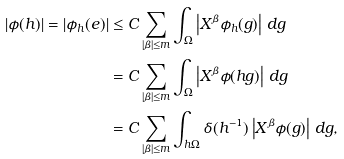<formula> <loc_0><loc_0><loc_500><loc_500>| \phi ( h ) | = | \phi _ { h } ( e ) | & \leq C \sum _ { | \beta | \leq m } \int _ { \Omega } \left | X ^ { \beta } \phi _ { h } ( g ) \right | \, d g \\ & = C \sum _ { | \beta | \leq m } \int _ { \Omega } \left | X ^ { \beta } \phi ( h g ) \right | \, d g \\ & = C \sum _ { | \beta | \leq m } \int _ { h \Omega } \delta ( h ^ { - 1 } ) \left | X ^ { \beta } \phi ( g ) \right | \, d g ,</formula> 